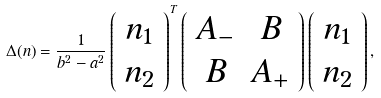<formula> <loc_0><loc_0><loc_500><loc_500>\Delta ( n ) = \frac { 1 } { b ^ { 2 } - a ^ { 2 } } \left ( \begin{array} { c } n _ { 1 } \\ n _ { 2 } \\ \end{array} \right ) ^ { T } \left ( \begin{array} { c c } A _ { - } & B \\ B & A _ { + } \\ \end{array} \right ) \left ( \begin{array} { c } n _ { 1 } \\ n _ { 2 } \\ \end{array} \right ) ,</formula> 